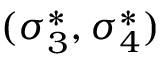Convert formula to latex. <formula><loc_0><loc_0><loc_500><loc_500>( \sigma _ { 3 } ^ { * } , \sigma _ { 4 } ^ { * } )</formula> 